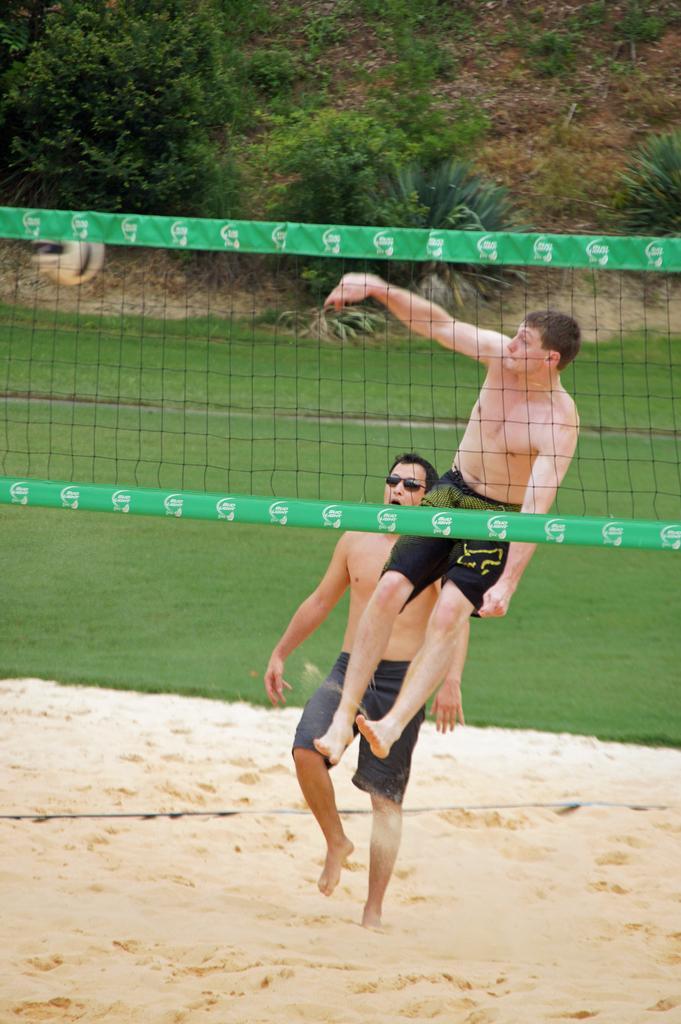How would you summarize this image in a sentence or two? In this image, we can see people and one of them is jumping. In the background, there are trees and we can see a net. At the bottom, there is ground and sand. 